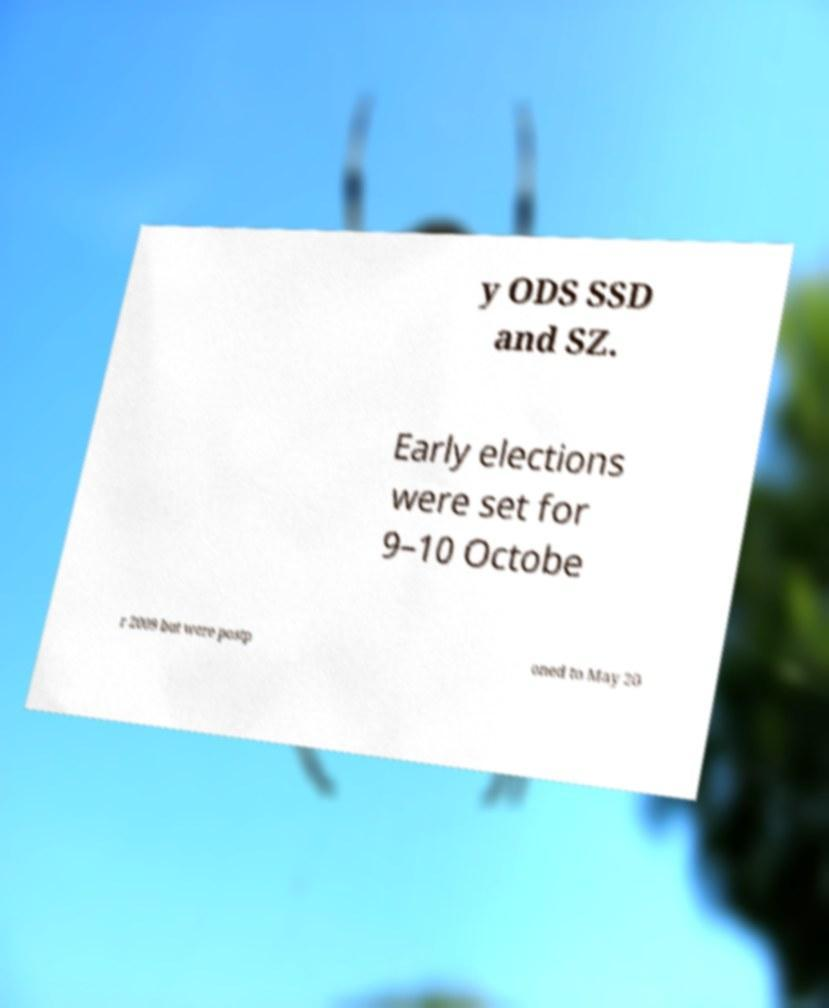There's text embedded in this image that I need extracted. Can you transcribe it verbatim? y ODS SSD and SZ. Early elections were set for 9–10 Octobe r 2009 but were postp oned to May 20 